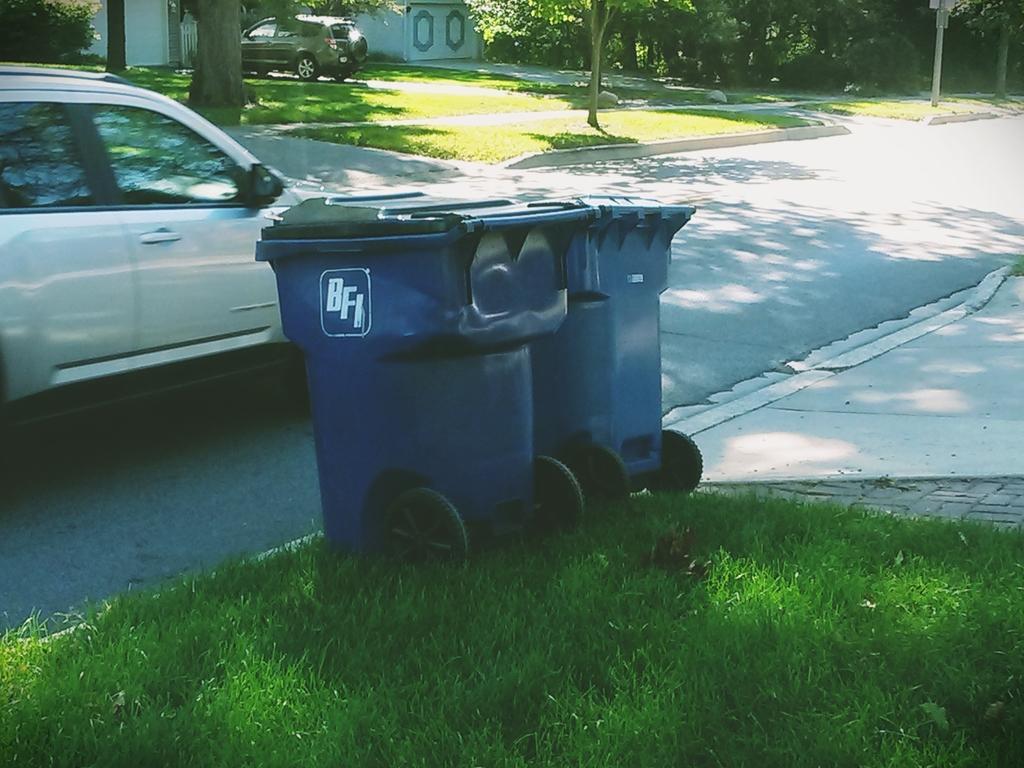Can you describe this image briefly? At the center of the image there are two dustbins on the surface of the grass, there is a vehicle on the road. In the background there is a building and a vehicle is parked, in front of the building there are trees. 